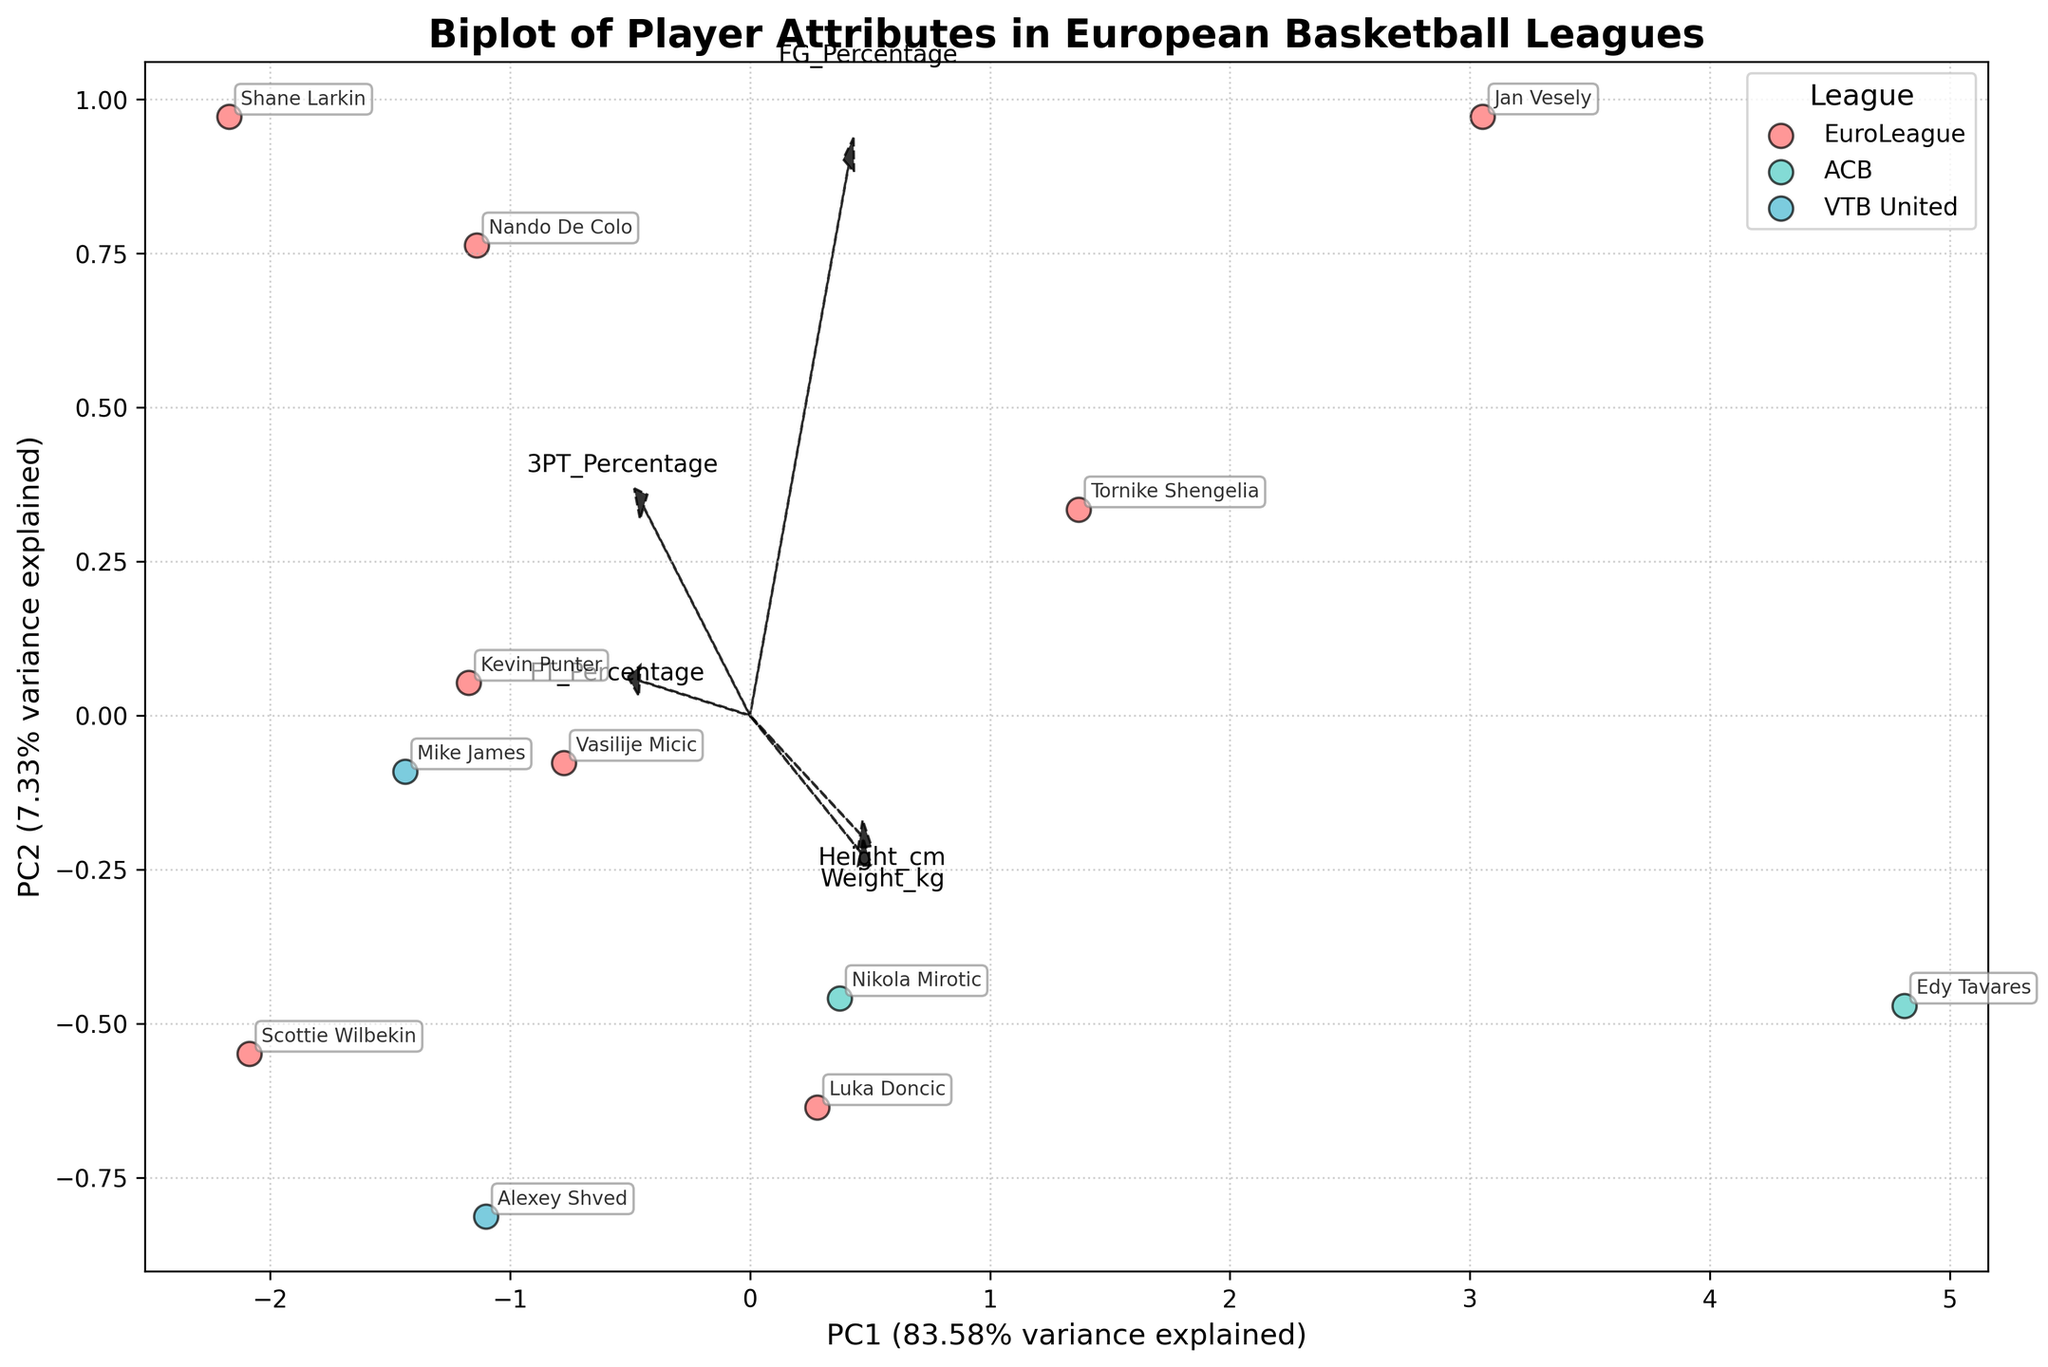What is the title of the biplot? The title can be found at the top of the biplot. It summarizes the overall purpose of the figure.
Answer: Biplot of Player Attributes in European Basketball Leagues How many data points are represented in the biplot? Each data point corresponds to a player in the dataset. By counting the individual points labeled with player names, we can determine the number of data points.
Answer: 12 Which feature vector points most closely towards the positive PC1 axis? By examining the direction of the arrows representing the feature vectors and their alignment with the PC1 axis, the one pointing closest to the positive PC1 axis can be identified.
Answer: Height_cm Which league has the highest density of players in the bottom-right quadrant? Looking at the distribution of players in different quadrants and the color representing each league, we determine which league has the most players in the specified quadrant.
Answer: EuroLeague Which player has the highest Free Throw Percentage (FT_Percentage)? By spotting the player whose position aligns closely with the FT_Percentage vector, specifically towards its positive direction, we can identify the player with the highest free throw percentage.
Answer: Nando De Colo How do the EuroLeague players compare to ACB players in terms of FG_Percentage? By comparing the positions of dots representing EuroLeague players and ACB players along the FG_Percentage vector, conclusions about their comparative field goal percentages can be drawn.
Answer: EuroLeague players have generally higher FG_Percentage What are the two PCs' variance explained percentages? The percentage of variance explained by PC1 and PC2 is indicated on the axes labels of the biplot. By reading these percentages, we know how much of the total variance is captured by the principal components.
Answer: PC1: 38.4%, PC2: 25.7% Do players with high 3 Point Percentage (3PT_Percentage) also have high Free Throw Percentage (FT_Percentage)? By examining the direction of the vectors for 3PT_Percentage and FT_Percentage, we check if players aligned positively along one vector are also aligned positively along the other vector.
Answer: Yes Which player stands out in terms of both height and weight? By locating the player that is distinctly positioned in the direction of both the Height_cm and Weight_kg vectors, we can identify the player who stands out.
Answer: Edy Tavares 